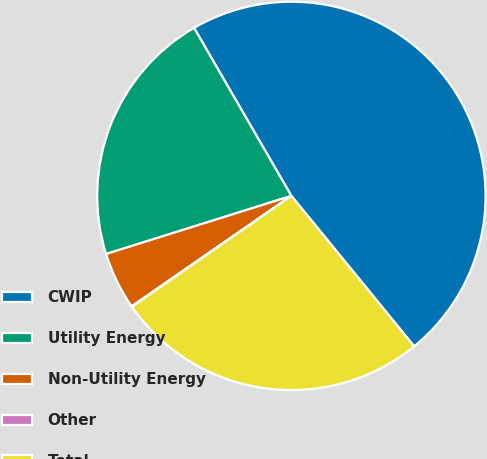Convert chart to OTSL. <chart><loc_0><loc_0><loc_500><loc_500><pie_chart><fcel>CWIP<fcel>Utility Energy<fcel>Non-Utility Energy<fcel>Other<fcel>Total<nl><fcel>47.46%<fcel>21.48%<fcel>4.79%<fcel>0.05%<fcel>26.22%<nl></chart> 